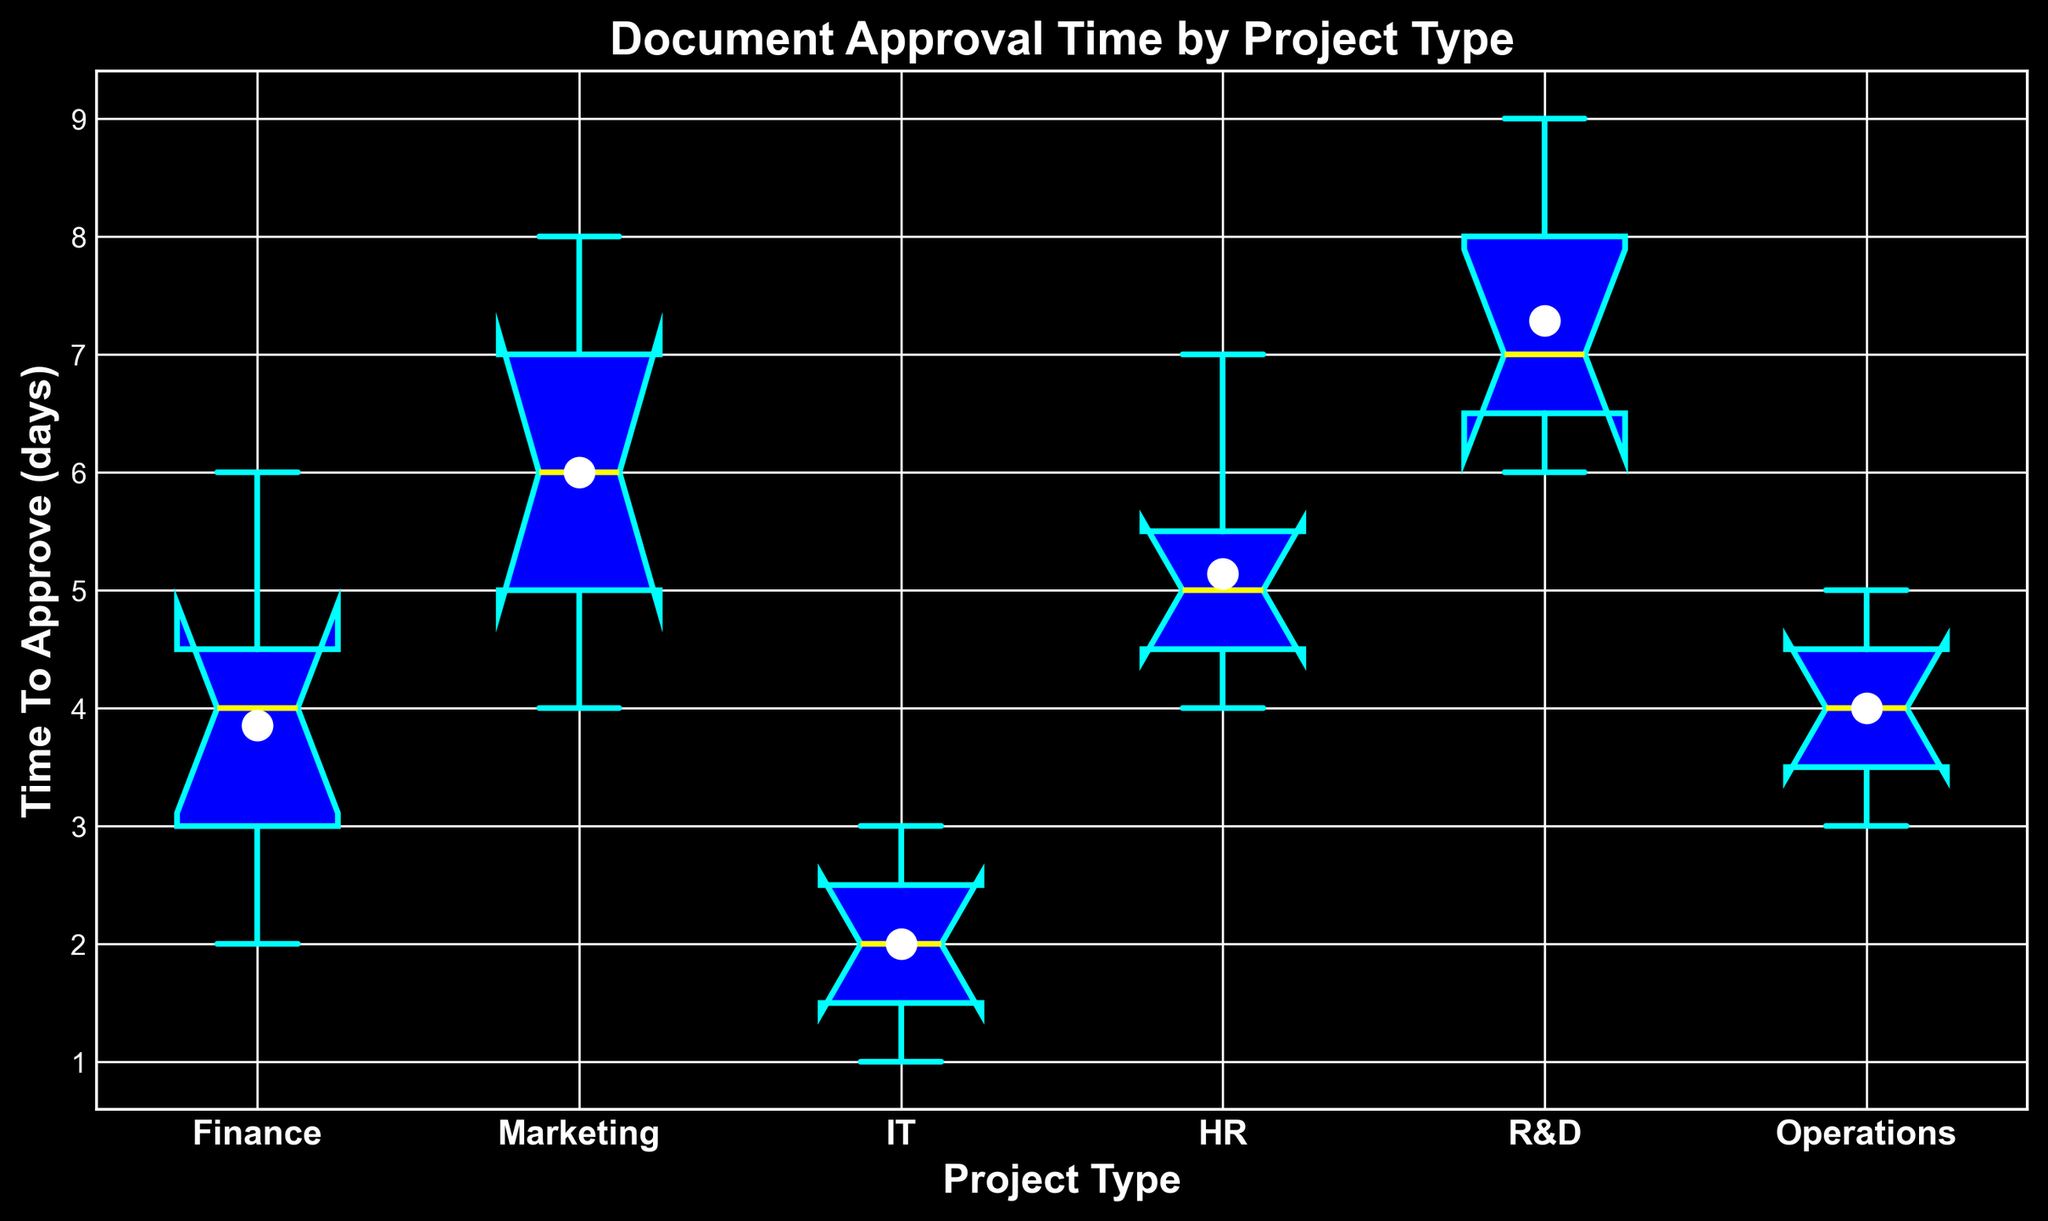What is the median time to approve documents for the Finance project type? To find the median time to approve documents for Finance, look at the box plot for the Finance category, and identify the middle value (median) which is represented by the line inside the box.
Answer: 4 Which project type has the highest mean approval time? To determine the project type with the highest mean approval time, look for the mean markers (small circles) in the box plots and compare their positions across all project types. The highest mean marker indicates the project type with the highest mean time.
Answer: R&D What is the range of approval times for the IT project type? To find the range of approval times for IT, identify the minimum (bottom whisker) and maximum (top whisker) values of the IT box plot. Subtract the minimum from the maximum.
Answer: 2 Which project type has the most variability in approval times? Variability can be assessed by the length of the box (interquartile range) and the length of the whiskers. The project type with the largest overall range from the bottom whisker to the top whisker indicates the most variability.
Answer: Marketing How does the median approval time for HR compare to that of Operations? Identify the median values (lines within the boxes) for both HR and Operations from their respective box plots. Compare the heights of these median lines.
Answer: HR is higher Which project type has the smallest interquartile range (IQR) for approval times? The IQR is represented by the height of the box itself (excluding whiskers). Find the project type where the box is the shortest vertically.
Answer: IT Is the mean approval time for the Marketing project type higher or lower than the median approval time for the same project type? Compare the position of the mean marker (small circle) in the Marketing box plot with the position of the median line within the same box.
Answer: Higher Compare the highest approval times (whiskers) between the Finance and R&D project types. Which one is higher? Identify the positions of the top whiskers for both Finance and R&D. The higher whisker indicates the higher maximum approval time.
Answer: R&D What is the approximate approval time at the 75th percentile for the Operations project type? The 75th percentile is represented by the top edge of the box in the box plot for Operations. Estimate the value at this edge.
Answer: 5 Are there any outliers in the approval times for the HR project type? Outliers are indicated by markers outside the whiskers of the box plot. Look for any points outside the HR whiskers.
Answer: No 